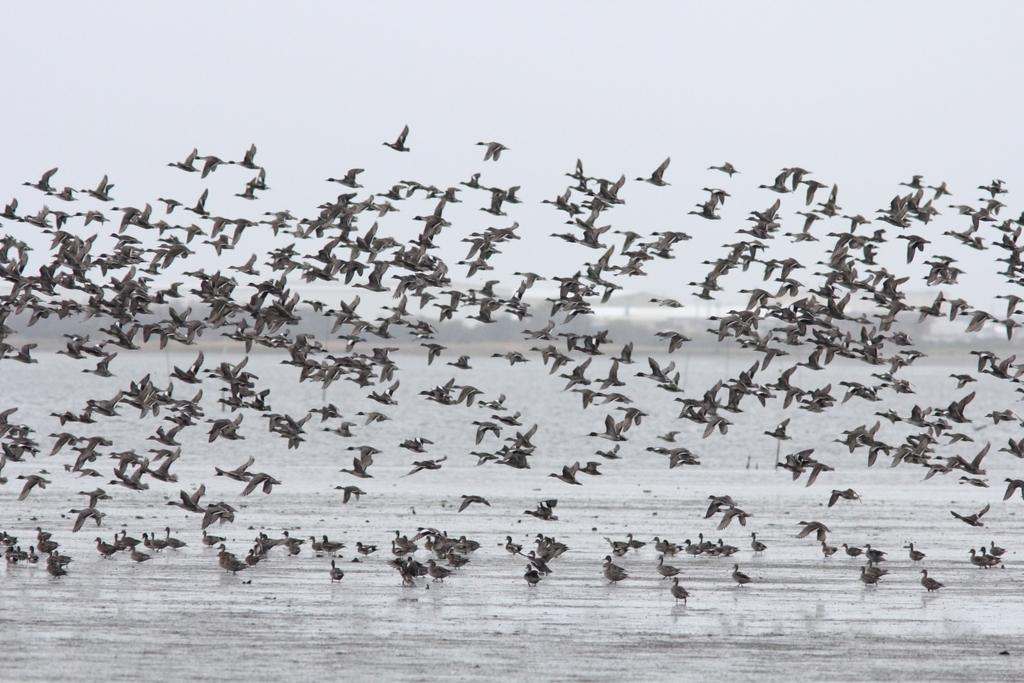What type of animals can be seen in the image? There are birds in the image. What is the primary element at the bottom of the image? There is a surface of water present at the bottom of the image. What can be seen in the background of the image? The sky is visible in the background of the image. What type of pest can be seen crawling on the hydrant in the image? There is no hydrant present in the image, and therefore no pest can be seen crawling on it. 